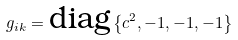Convert formula to latex. <formula><loc_0><loc_0><loc_500><loc_500>g _ { i k } = \text {diag} \left \{ c ^ { 2 } , - 1 , - 1 , - 1 \right \}</formula> 